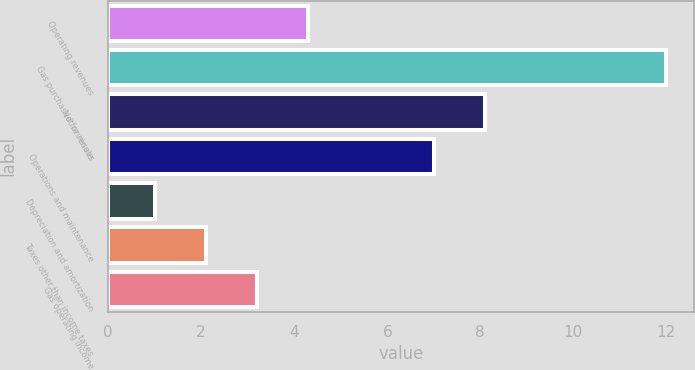<chart> <loc_0><loc_0><loc_500><loc_500><bar_chart><fcel>Operating revenues<fcel>Gas purchased for resale<fcel>Net revenues<fcel>Operations and maintenance<fcel>Depreciation and amortization<fcel>Taxes other than income taxes<fcel>Gas operating income<nl><fcel>4.3<fcel>12<fcel>8.1<fcel>7<fcel>1<fcel>2.1<fcel>3.2<nl></chart> 